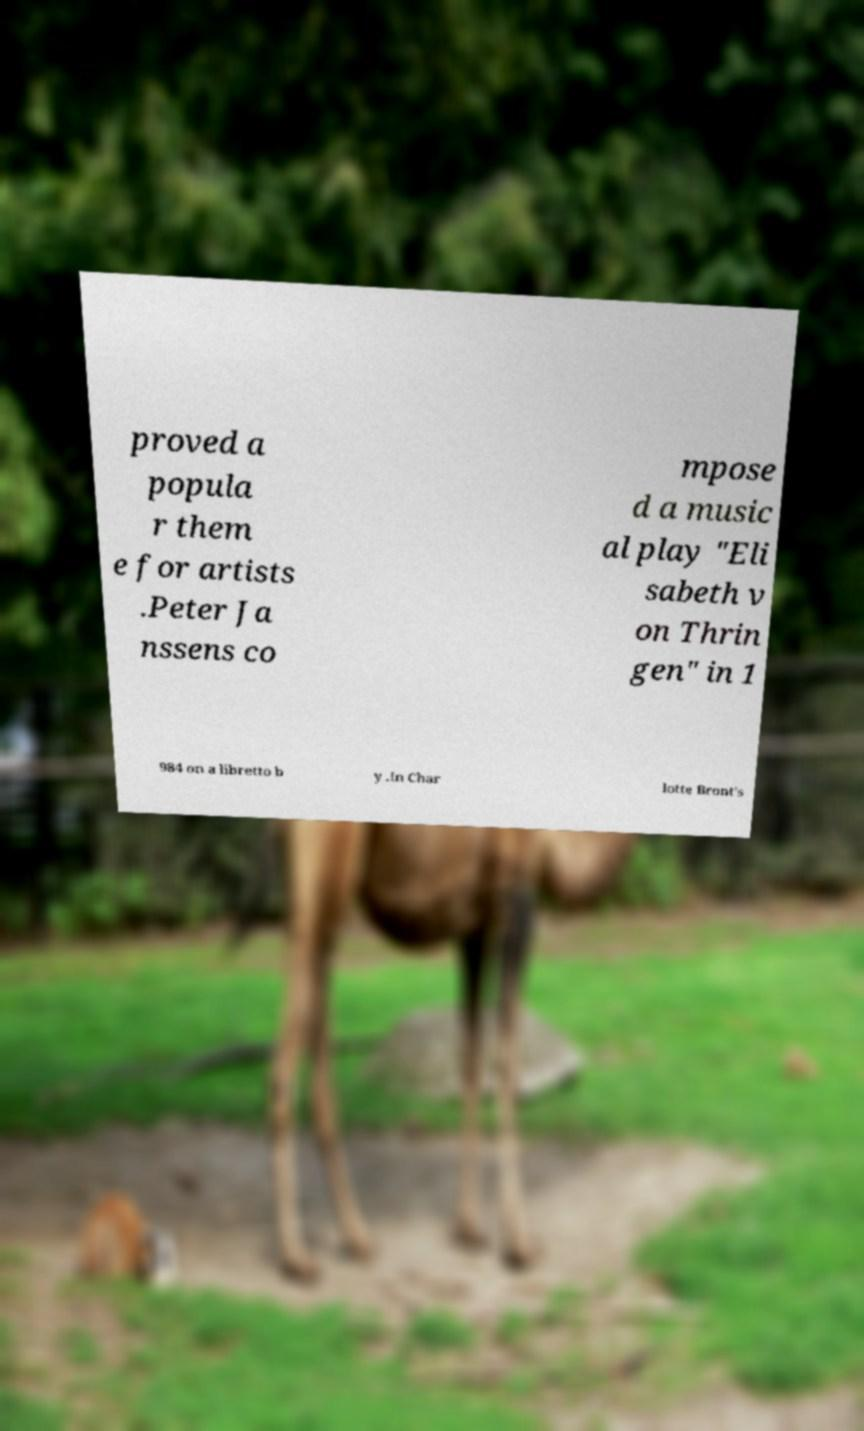Please read and relay the text visible in this image. What does it say? proved a popula r them e for artists .Peter Ja nssens co mpose d a music al play "Eli sabeth v on Thrin gen" in 1 984 on a libretto b y .In Char lotte Bront's 